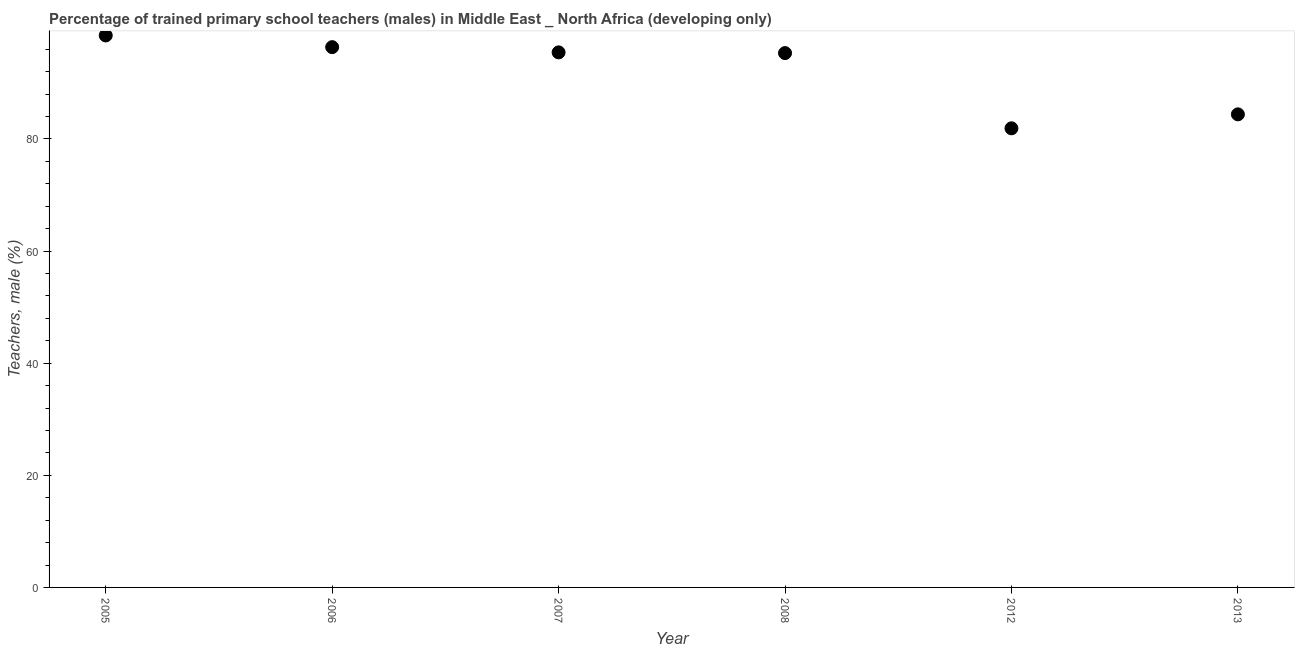What is the percentage of trained male teachers in 2006?
Provide a succinct answer. 96.38. Across all years, what is the maximum percentage of trained male teachers?
Your response must be concise. 98.46. Across all years, what is the minimum percentage of trained male teachers?
Ensure brevity in your answer.  81.9. What is the sum of the percentage of trained male teachers?
Keep it short and to the point. 551.89. What is the difference between the percentage of trained male teachers in 2006 and 2008?
Give a very brief answer. 1.06. What is the average percentage of trained male teachers per year?
Provide a short and direct response. 91.98. What is the median percentage of trained male teachers?
Make the answer very short. 95.38. In how many years, is the percentage of trained male teachers greater than 48 %?
Provide a short and direct response. 6. What is the ratio of the percentage of trained male teachers in 2006 to that in 2013?
Offer a very short reply. 1.14. Is the difference between the percentage of trained male teachers in 2005 and 2007 greater than the difference between any two years?
Your answer should be compact. No. What is the difference between the highest and the second highest percentage of trained male teachers?
Provide a succinct answer. 2.08. Is the sum of the percentage of trained male teachers in 2005 and 2012 greater than the maximum percentage of trained male teachers across all years?
Keep it short and to the point. Yes. What is the difference between the highest and the lowest percentage of trained male teachers?
Your response must be concise. 16.56. In how many years, is the percentage of trained male teachers greater than the average percentage of trained male teachers taken over all years?
Make the answer very short. 4. How many years are there in the graph?
Your answer should be very brief. 6. Are the values on the major ticks of Y-axis written in scientific E-notation?
Your response must be concise. No. Does the graph contain any zero values?
Your response must be concise. No. What is the title of the graph?
Offer a terse response. Percentage of trained primary school teachers (males) in Middle East _ North Africa (developing only). What is the label or title of the Y-axis?
Provide a succinct answer. Teachers, male (%). What is the Teachers, male (%) in 2005?
Your answer should be very brief. 98.46. What is the Teachers, male (%) in 2006?
Your response must be concise. 96.38. What is the Teachers, male (%) in 2007?
Keep it short and to the point. 95.45. What is the Teachers, male (%) in 2008?
Your answer should be compact. 95.32. What is the Teachers, male (%) in 2012?
Your answer should be compact. 81.9. What is the Teachers, male (%) in 2013?
Provide a short and direct response. 84.39. What is the difference between the Teachers, male (%) in 2005 and 2006?
Keep it short and to the point. 2.08. What is the difference between the Teachers, male (%) in 2005 and 2007?
Your answer should be compact. 3.01. What is the difference between the Teachers, male (%) in 2005 and 2008?
Your answer should be compact. 3.14. What is the difference between the Teachers, male (%) in 2005 and 2012?
Offer a terse response. 16.56. What is the difference between the Teachers, male (%) in 2005 and 2013?
Ensure brevity in your answer.  14.07. What is the difference between the Teachers, male (%) in 2006 and 2007?
Offer a very short reply. 0.93. What is the difference between the Teachers, male (%) in 2006 and 2008?
Provide a short and direct response. 1.06. What is the difference between the Teachers, male (%) in 2006 and 2012?
Offer a terse response. 14.48. What is the difference between the Teachers, male (%) in 2006 and 2013?
Provide a succinct answer. 11.99. What is the difference between the Teachers, male (%) in 2007 and 2008?
Provide a short and direct response. 0.13. What is the difference between the Teachers, male (%) in 2007 and 2012?
Your answer should be very brief. 13.55. What is the difference between the Teachers, male (%) in 2007 and 2013?
Make the answer very short. 11.06. What is the difference between the Teachers, male (%) in 2008 and 2012?
Offer a terse response. 13.42. What is the difference between the Teachers, male (%) in 2008 and 2013?
Make the answer very short. 10.93. What is the difference between the Teachers, male (%) in 2012 and 2013?
Your answer should be compact. -2.49. What is the ratio of the Teachers, male (%) in 2005 to that in 2006?
Offer a very short reply. 1.02. What is the ratio of the Teachers, male (%) in 2005 to that in 2007?
Ensure brevity in your answer.  1.03. What is the ratio of the Teachers, male (%) in 2005 to that in 2008?
Provide a succinct answer. 1.03. What is the ratio of the Teachers, male (%) in 2005 to that in 2012?
Offer a terse response. 1.2. What is the ratio of the Teachers, male (%) in 2005 to that in 2013?
Offer a very short reply. 1.17. What is the ratio of the Teachers, male (%) in 2006 to that in 2007?
Your answer should be compact. 1.01. What is the ratio of the Teachers, male (%) in 2006 to that in 2012?
Provide a succinct answer. 1.18. What is the ratio of the Teachers, male (%) in 2006 to that in 2013?
Make the answer very short. 1.14. What is the ratio of the Teachers, male (%) in 2007 to that in 2012?
Your answer should be compact. 1.17. What is the ratio of the Teachers, male (%) in 2007 to that in 2013?
Ensure brevity in your answer.  1.13. What is the ratio of the Teachers, male (%) in 2008 to that in 2012?
Offer a terse response. 1.16. What is the ratio of the Teachers, male (%) in 2008 to that in 2013?
Provide a short and direct response. 1.13. 